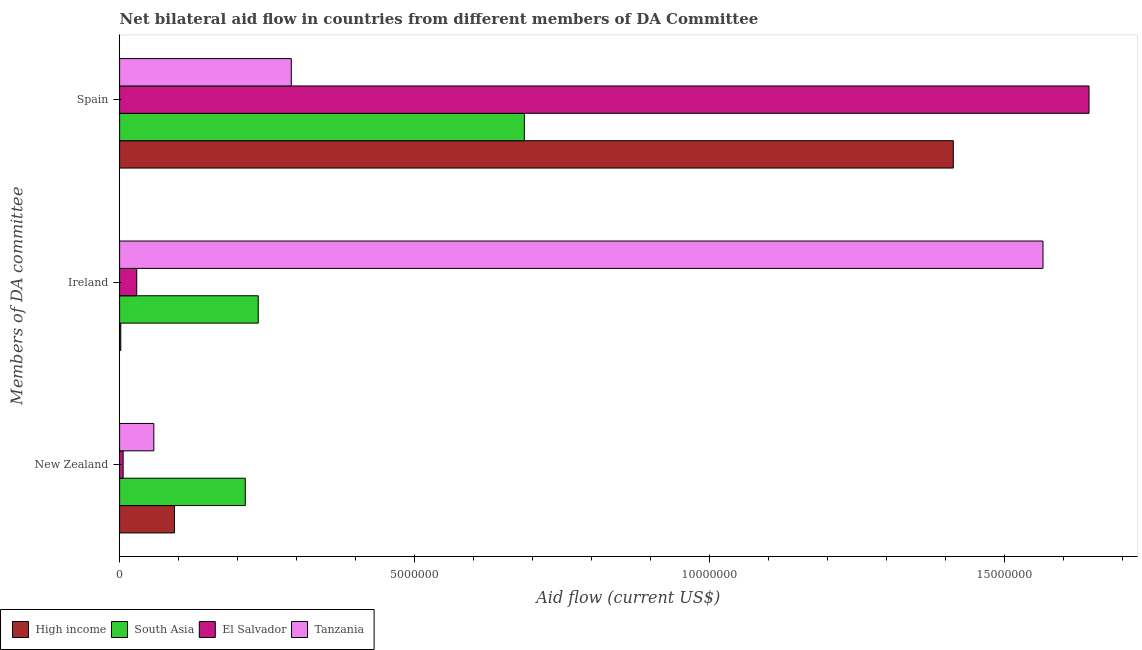How many groups of bars are there?
Your answer should be compact. 3. How many bars are there on the 3rd tick from the top?
Give a very brief answer. 4. What is the label of the 3rd group of bars from the top?
Offer a terse response. New Zealand. What is the amount of aid provided by new zealand in Tanzania?
Offer a terse response. 5.80e+05. Across all countries, what is the maximum amount of aid provided by spain?
Give a very brief answer. 1.64e+07. Across all countries, what is the minimum amount of aid provided by ireland?
Offer a terse response. 2.00e+04. In which country was the amount of aid provided by new zealand maximum?
Ensure brevity in your answer.  South Asia. In which country was the amount of aid provided by ireland minimum?
Provide a succinct answer. High income. What is the total amount of aid provided by new zealand in the graph?
Provide a short and direct response. 3.70e+06. What is the difference between the amount of aid provided by spain in High income and that in El Salvador?
Give a very brief answer. -2.30e+06. What is the difference between the amount of aid provided by spain in High income and the amount of aid provided by new zealand in Tanzania?
Provide a short and direct response. 1.36e+07. What is the average amount of aid provided by spain per country?
Your answer should be very brief. 1.01e+07. What is the difference between the amount of aid provided by new zealand and amount of aid provided by ireland in South Asia?
Provide a succinct answer. -2.20e+05. What is the ratio of the amount of aid provided by new zealand in El Salvador to that in High income?
Your answer should be compact. 0.06. What is the difference between the highest and the second highest amount of aid provided by spain?
Offer a terse response. 2.30e+06. What is the difference between the highest and the lowest amount of aid provided by new zealand?
Ensure brevity in your answer.  2.07e+06. In how many countries, is the amount of aid provided by ireland greater than the average amount of aid provided by ireland taken over all countries?
Ensure brevity in your answer.  1. Is the sum of the amount of aid provided by spain in High income and South Asia greater than the maximum amount of aid provided by new zealand across all countries?
Your response must be concise. Yes. What does the 2nd bar from the top in Ireland represents?
Your answer should be very brief. El Salvador. What does the 4th bar from the bottom in New Zealand represents?
Offer a very short reply. Tanzania. Is it the case that in every country, the sum of the amount of aid provided by new zealand and amount of aid provided by ireland is greater than the amount of aid provided by spain?
Give a very brief answer. No. How many bars are there?
Provide a short and direct response. 12. Are all the bars in the graph horizontal?
Ensure brevity in your answer.  Yes. How many countries are there in the graph?
Ensure brevity in your answer.  4. Does the graph contain any zero values?
Offer a terse response. No. Does the graph contain grids?
Offer a terse response. No. Where does the legend appear in the graph?
Keep it short and to the point. Bottom left. How are the legend labels stacked?
Keep it short and to the point. Horizontal. What is the title of the graph?
Make the answer very short. Net bilateral aid flow in countries from different members of DA Committee. Does "Belize" appear as one of the legend labels in the graph?
Offer a very short reply. No. What is the label or title of the Y-axis?
Provide a succinct answer. Members of DA committee. What is the Aid flow (current US$) of High income in New Zealand?
Your answer should be compact. 9.30e+05. What is the Aid flow (current US$) of South Asia in New Zealand?
Ensure brevity in your answer.  2.13e+06. What is the Aid flow (current US$) in El Salvador in New Zealand?
Offer a very short reply. 6.00e+04. What is the Aid flow (current US$) of Tanzania in New Zealand?
Offer a terse response. 5.80e+05. What is the Aid flow (current US$) in South Asia in Ireland?
Provide a succinct answer. 2.35e+06. What is the Aid flow (current US$) of El Salvador in Ireland?
Your answer should be very brief. 2.90e+05. What is the Aid flow (current US$) in Tanzania in Ireland?
Ensure brevity in your answer.  1.56e+07. What is the Aid flow (current US$) in High income in Spain?
Keep it short and to the point. 1.41e+07. What is the Aid flow (current US$) of South Asia in Spain?
Offer a terse response. 6.86e+06. What is the Aid flow (current US$) in El Salvador in Spain?
Ensure brevity in your answer.  1.64e+07. What is the Aid flow (current US$) in Tanzania in Spain?
Ensure brevity in your answer.  2.91e+06. Across all Members of DA committee, what is the maximum Aid flow (current US$) in High income?
Make the answer very short. 1.41e+07. Across all Members of DA committee, what is the maximum Aid flow (current US$) of South Asia?
Your answer should be compact. 6.86e+06. Across all Members of DA committee, what is the maximum Aid flow (current US$) in El Salvador?
Provide a short and direct response. 1.64e+07. Across all Members of DA committee, what is the maximum Aid flow (current US$) in Tanzania?
Your response must be concise. 1.56e+07. Across all Members of DA committee, what is the minimum Aid flow (current US$) in South Asia?
Your answer should be very brief. 2.13e+06. Across all Members of DA committee, what is the minimum Aid flow (current US$) in El Salvador?
Your answer should be very brief. 6.00e+04. Across all Members of DA committee, what is the minimum Aid flow (current US$) in Tanzania?
Your response must be concise. 5.80e+05. What is the total Aid flow (current US$) in High income in the graph?
Provide a short and direct response. 1.51e+07. What is the total Aid flow (current US$) of South Asia in the graph?
Provide a succinct answer. 1.13e+07. What is the total Aid flow (current US$) of El Salvador in the graph?
Offer a very short reply. 1.68e+07. What is the total Aid flow (current US$) in Tanzania in the graph?
Offer a very short reply. 1.91e+07. What is the difference between the Aid flow (current US$) of High income in New Zealand and that in Ireland?
Offer a terse response. 9.10e+05. What is the difference between the Aid flow (current US$) in South Asia in New Zealand and that in Ireland?
Your answer should be compact. -2.20e+05. What is the difference between the Aid flow (current US$) of El Salvador in New Zealand and that in Ireland?
Offer a terse response. -2.30e+05. What is the difference between the Aid flow (current US$) of Tanzania in New Zealand and that in Ireland?
Your response must be concise. -1.51e+07. What is the difference between the Aid flow (current US$) in High income in New Zealand and that in Spain?
Your answer should be compact. -1.32e+07. What is the difference between the Aid flow (current US$) of South Asia in New Zealand and that in Spain?
Make the answer very short. -4.73e+06. What is the difference between the Aid flow (current US$) of El Salvador in New Zealand and that in Spain?
Provide a succinct answer. -1.64e+07. What is the difference between the Aid flow (current US$) of Tanzania in New Zealand and that in Spain?
Your response must be concise. -2.33e+06. What is the difference between the Aid flow (current US$) in High income in Ireland and that in Spain?
Keep it short and to the point. -1.41e+07. What is the difference between the Aid flow (current US$) in South Asia in Ireland and that in Spain?
Provide a short and direct response. -4.51e+06. What is the difference between the Aid flow (current US$) in El Salvador in Ireland and that in Spain?
Your answer should be compact. -1.61e+07. What is the difference between the Aid flow (current US$) of Tanzania in Ireland and that in Spain?
Your answer should be very brief. 1.27e+07. What is the difference between the Aid flow (current US$) of High income in New Zealand and the Aid flow (current US$) of South Asia in Ireland?
Your response must be concise. -1.42e+06. What is the difference between the Aid flow (current US$) in High income in New Zealand and the Aid flow (current US$) in El Salvador in Ireland?
Your answer should be compact. 6.40e+05. What is the difference between the Aid flow (current US$) of High income in New Zealand and the Aid flow (current US$) of Tanzania in Ireland?
Make the answer very short. -1.47e+07. What is the difference between the Aid flow (current US$) in South Asia in New Zealand and the Aid flow (current US$) in El Salvador in Ireland?
Offer a terse response. 1.84e+06. What is the difference between the Aid flow (current US$) of South Asia in New Zealand and the Aid flow (current US$) of Tanzania in Ireland?
Your answer should be compact. -1.35e+07. What is the difference between the Aid flow (current US$) in El Salvador in New Zealand and the Aid flow (current US$) in Tanzania in Ireland?
Your response must be concise. -1.56e+07. What is the difference between the Aid flow (current US$) of High income in New Zealand and the Aid flow (current US$) of South Asia in Spain?
Give a very brief answer. -5.93e+06. What is the difference between the Aid flow (current US$) of High income in New Zealand and the Aid flow (current US$) of El Salvador in Spain?
Give a very brief answer. -1.55e+07. What is the difference between the Aid flow (current US$) in High income in New Zealand and the Aid flow (current US$) in Tanzania in Spain?
Make the answer very short. -1.98e+06. What is the difference between the Aid flow (current US$) of South Asia in New Zealand and the Aid flow (current US$) of El Salvador in Spain?
Offer a terse response. -1.43e+07. What is the difference between the Aid flow (current US$) in South Asia in New Zealand and the Aid flow (current US$) in Tanzania in Spain?
Make the answer very short. -7.80e+05. What is the difference between the Aid flow (current US$) in El Salvador in New Zealand and the Aid flow (current US$) in Tanzania in Spain?
Provide a short and direct response. -2.85e+06. What is the difference between the Aid flow (current US$) in High income in Ireland and the Aid flow (current US$) in South Asia in Spain?
Ensure brevity in your answer.  -6.84e+06. What is the difference between the Aid flow (current US$) of High income in Ireland and the Aid flow (current US$) of El Salvador in Spain?
Keep it short and to the point. -1.64e+07. What is the difference between the Aid flow (current US$) of High income in Ireland and the Aid flow (current US$) of Tanzania in Spain?
Keep it short and to the point. -2.89e+06. What is the difference between the Aid flow (current US$) of South Asia in Ireland and the Aid flow (current US$) of El Salvador in Spain?
Make the answer very short. -1.41e+07. What is the difference between the Aid flow (current US$) of South Asia in Ireland and the Aid flow (current US$) of Tanzania in Spain?
Give a very brief answer. -5.60e+05. What is the difference between the Aid flow (current US$) in El Salvador in Ireland and the Aid flow (current US$) in Tanzania in Spain?
Make the answer very short. -2.62e+06. What is the average Aid flow (current US$) of High income per Members of DA committee?
Your response must be concise. 5.03e+06. What is the average Aid flow (current US$) of South Asia per Members of DA committee?
Keep it short and to the point. 3.78e+06. What is the average Aid flow (current US$) of El Salvador per Members of DA committee?
Offer a terse response. 5.59e+06. What is the average Aid flow (current US$) in Tanzania per Members of DA committee?
Offer a very short reply. 6.38e+06. What is the difference between the Aid flow (current US$) in High income and Aid flow (current US$) in South Asia in New Zealand?
Offer a terse response. -1.20e+06. What is the difference between the Aid flow (current US$) in High income and Aid flow (current US$) in El Salvador in New Zealand?
Offer a terse response. 8.70e+05. What is the difference between the Aid flow (current US$) in South Asia and Aid flow (current US$) in El Salvador in New Zealand?
Provide a short and direct response. 2.07e+06. What is the difference between the Aid flow (current US$) of South Asia and Aid flow (current US$) of Tanzania in New Zealand?
Give a very brief answer. 1.55e+06. What is the difference between the Aid flow (current US$) of El Salvador and Aid flow (current US$) of Tanzania in New Zealand?
Provide a short and direct response. -5.20e+05. What is the difference between the Aid flow (current US$) in High income and Aid flow (current US$) in South Asia in Ireland?
Make the answer very short. -2.33e+06. What is the difference between the Aid flow (current US$) in High income and Aid flow (current US$) in El Salvador in Ireland?
Your response must be concise. -2.70e+05. What is the difference between the Aid flow (current US$) in High income and Aid flow (current US$) in Tanzania in Ireland?
Ensure brevity in your answer.  -1.56e+07. What is the difference between the Aid flow (current US$) in South Asia and Aid flow (current US$) in El Salvador in Ireland?
Your response must be concise. 2.06e+06. What is the difference between the Aid flow (current US$) of South Asia and Aid flow (current US$) of Tanzania in Ireland?
Your answer should be very brief. -1.33e+07. What is the difference between the Aid flow (current US$) of El Salvador and Aid flow (current US$) of Tanzania in Ireland?
Make the answer very short. -1.54e+07. What is the difference between the Aid flow (current US$) in High income and Aid flow (current US$) in South Asia in Spain?
Provide a succinct answer. 7.27e+06. What is the difference between the Aid flow (current US$) in High income and Aid flow (current US$) in El Salvador in Spain?
Provide a short and direct response. -2.30e+06. What is the difference between the Aid flow (current US$) of High income and Aid flow (current US$) of Tanzania in Spain?
Your answer should be very brief. 1.12e+07. What is the difference between the Aid flow (current US$) of South Asia and Aid flow (current US$) of El Salvador in Spain?
Provide a short and direct response. -9.57e+06. What is the difference between the Aid flow (current US$) of South Asia and Aid flow (current US$) of Tanzania in Spain?
Your response must be concise. 3.95e+06. What is the difference between the Aid flow (current US$) in El Salvador and Aid flow (current US$) in Tanzania in Spain?
Ensure brevity in your answer.  1.35e+07. What is the ratio of the Aid flow (current US$) of High income in New Zealand to that in Ireland?
Make the answer very short. 46.5. What is the ratio of the Aid flow (current US$) in South Asia in New Zealand to that in Ireland?
Provide a succinct answer. 0.91. What is the ratio of the Aid flow (current US$) in El Salvador in New Zealand to that in Ireland?
Provide a succinct answer. 0.21. What is the ratio of the Aid flow (current US$) of Tanzania in New Zealand to that in Ireland?
Your answer should be compact. 0.04. What is the ratio of the Aid flow (current US$) of High income in New Zealand to that in Spain?
Your answer should be very brief. 0.07. What is the ratio of the Aid flow (current US$) of South Asia in New Zealand to that in Spain?
Your answer should be very brief. 0.31. What is the ratio of the Aid flow (current US$) of El Salvador in New Zealand to that in Spain?
Keep it short and to the point. 0. What is the ratio of the Aid flow (current US$) in Tanzania in New Zealand to that in Spain?
Keep it short and to the point. 0.2. What is the ratio of the Aid flow (current US$) of High income in Ireland to that in Spain?
Keep it short and to the point. 0. What is the ratio of the Aid flow (current US$) of South Asia in Ireland to that in Spain?
Provide a short and direct response. 0.34. What is the ratio of the Aid flow (current US$) in El Salvador in Ireland to that in Spain?
Provide a short and direct response. 0.02. What is the ratio of the Aid flow (current US$) in Tanzania in Ireland to that in Spain?
Your answer should be very brief. 5.38. What is the difference between the highest and the second highest Aid flow (current US$) of High income?
Your answer should be very brief. 1.32e+07. What is the difference between the highest and the second highest Aid flow (current US$) of South Asia?
Provide a short and direct response. 4.51e+06. What is the difference between the highest and the second highest Aid flow (current US$) of El Salvador?
Give a very brief answer. 1.61e+07. What is the difference between the highest and the second highest Aid flow (current US$) of Tanzania?
Ensure brevity in your answer.  1.27e+07. What is the difference between the highest and the lowest Aid flow (current US$) of High income?
Provide a succinct answer. 1.41e+07. What is the difference between the highest and the lowest Aid flow (current US$) in South Asia?
Provide a succinct answer. 4.73e+06. What is the difference between the highest and the lowest Aid flow (current US$) of El Salvador?
Provide a short and direct response. 1.64e+07. What is the difference between the highest and the lowest Aid flow (current US$) of Tanzania?
Give a very brief answer. 1.51e+07. 